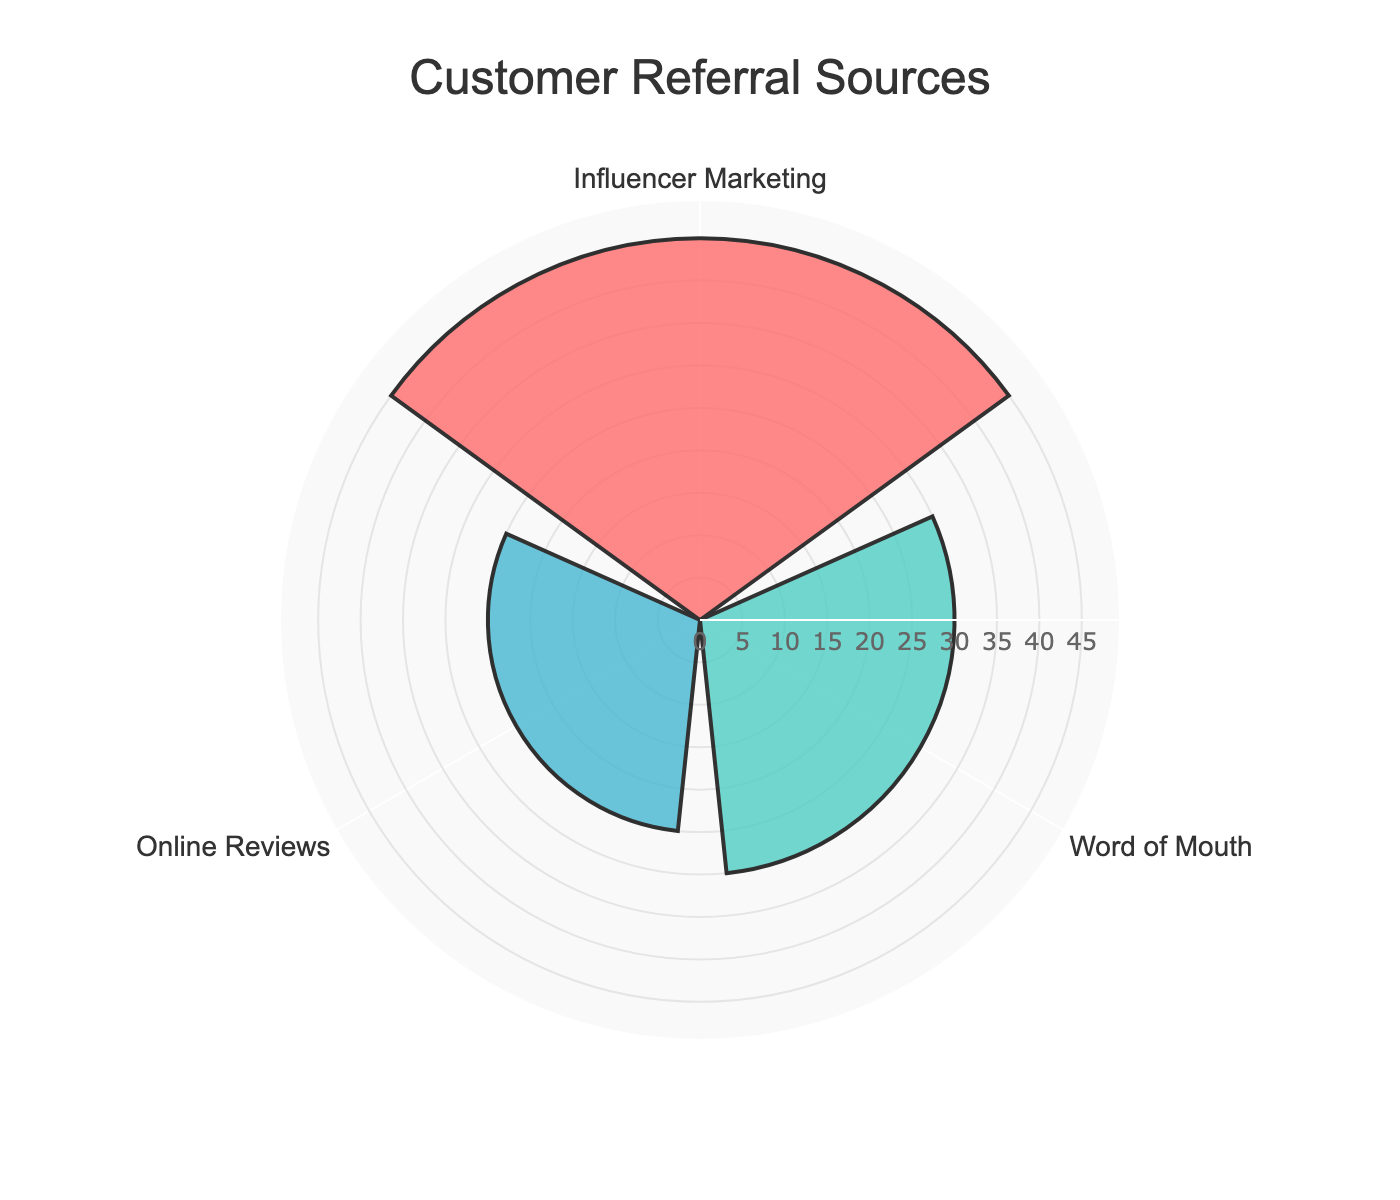What are the colors used for each source of customer referrals? The rose chart uses different colors to represent each source of customer referrals: Influencer Marketing is represented by a red color, Word of Mouth by a green color, and Online Reviews by a blue color.
Answer: Red for Influencer Marketing, Green for Word of Mouth, Blue for Online Reviews What is the largest source of customer referrals? By looking at the lengths of the bars in the rose chart, Influencer Marketing has the highest value among the sources.
Answer: Influencer Marketing What is the value of Word of Mouth referrals? On the rose chart, the value corresponding to Word of Mouth is given as 30.
Answer: 30 What is the difference in the number of referrals between Influencer Marketing and Online Reviews? Influencer Marketing has 45 referrals, and Online Reviews has 25. The difference is calculated as 45 - 25 = 20.
Answer: 20 Which referral source has the lowest number of referrals? By comparing the lengths of the bars, Online Reviews have the lowest number of referrals among the sources.
Answer: Online Reviews What percentage of total referrals come from Word of Mouth? The total number of referrals is 45 (Influencer Marketing) + 30 (Word of Mouth) + 25 (Online Reviews) = 100. The percentage from Word of Mouth is (30 / 100) * 100 = 30%.
Answer: 30% How much more effective is Influencer Marketing compared to Word of Mouth in terms of referrals? Influencer Marketing has 45 referrals while Word of Mouth has 30. The number of additional referrals is 45 - 30 = 15. Therefore, Influencer Marketing is 15 referrals more effective.
Answer: 15 referrals more effective What is the total number of customer referrals shown in the chart? Adding the values from all sources: 45 (Influencer Marketing) + 30 (Word of Mouth) + 25 (Online Reviews) = 100.
Answer: 100 What is the average number of referrals per source? The total number of referrals is 100, and there are 3 sources. The average is calculated as 100 / 3 ≈ 33.33.
Answer: 33.33 What is the median value of the three sources of customer referrals? The three values are 45, 30, and 25. Arranging them in ascending order gives 25, 30, and 45. The middle value is the median, which is 30.
Answer: 30 